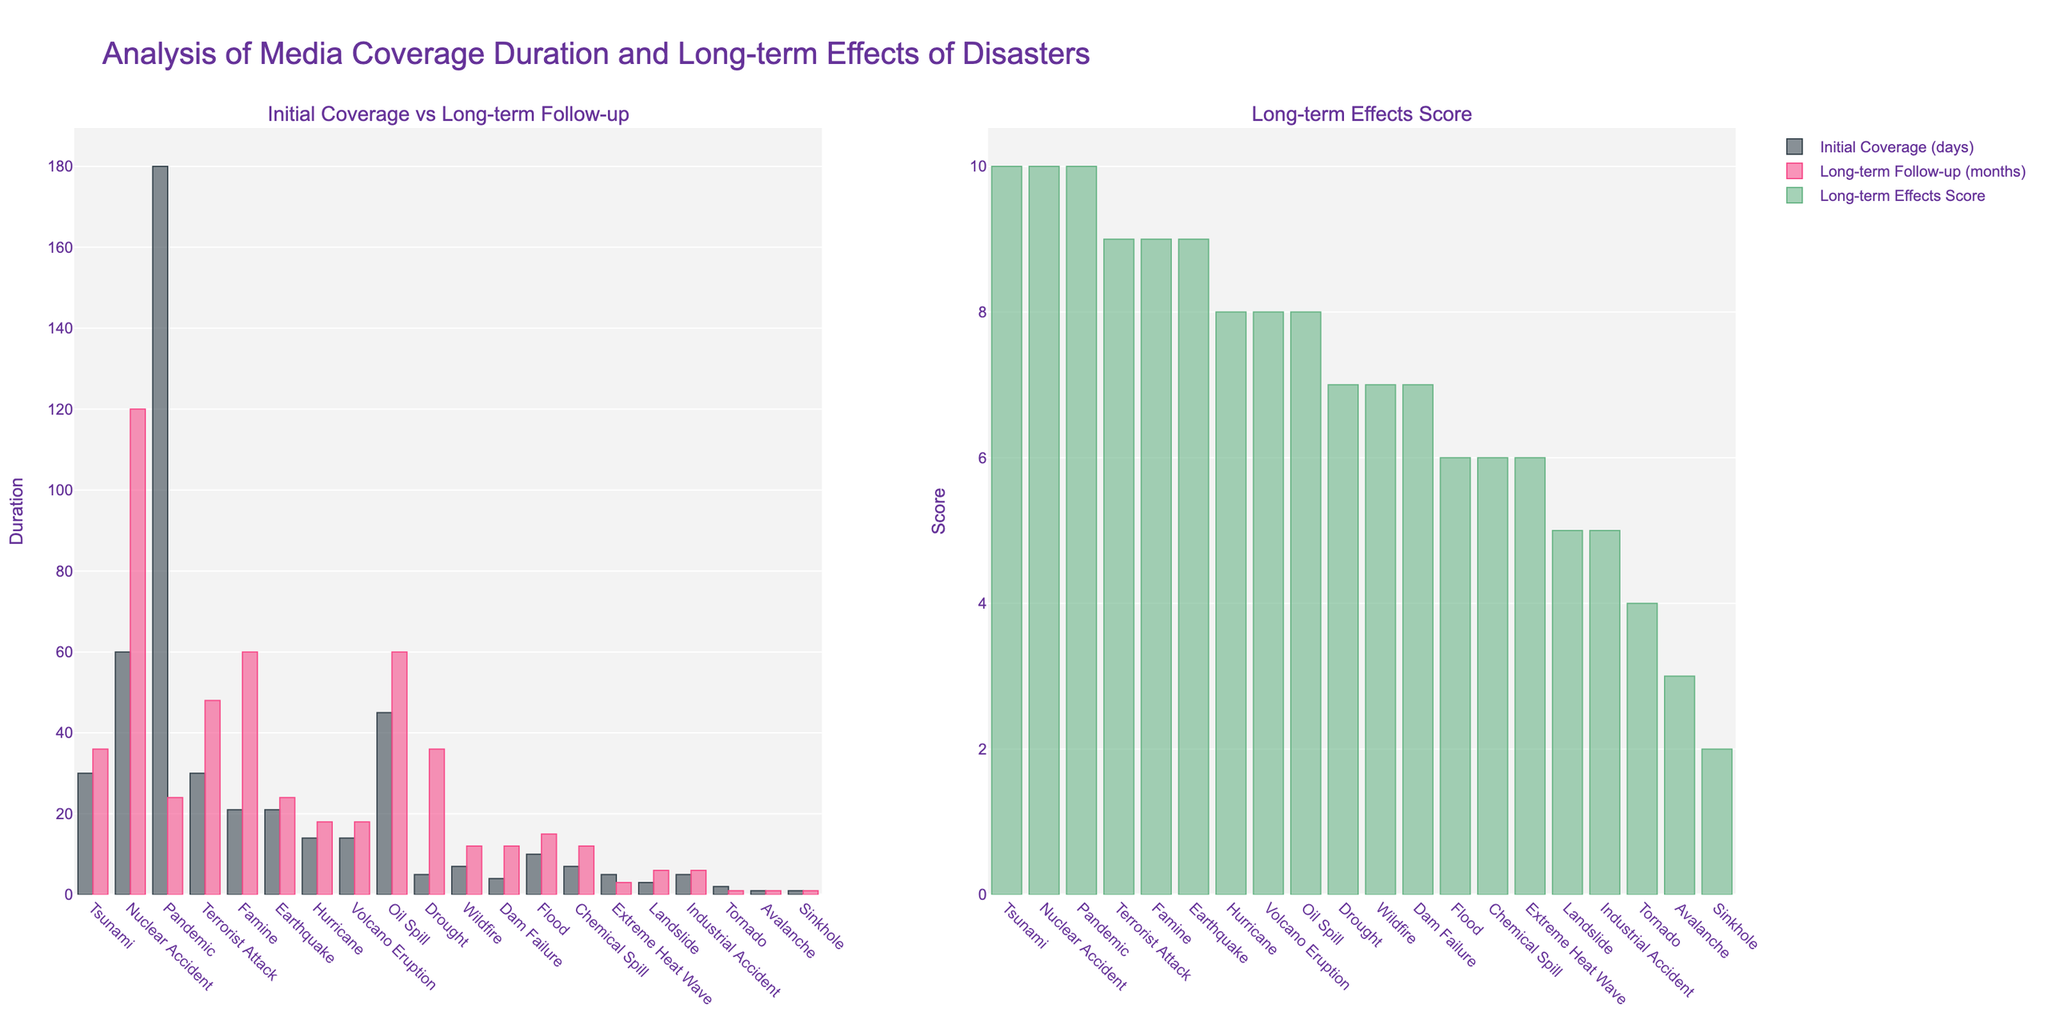What disaster type has the highest initial coverage and what is it? To identify the disaster with the highest initial coverage, observe the height of the bars in the "Initial Coverage (days)" trace. The highest bar represents the disaster with the most days of initial coverage.
Answer: Pandemic, 180 days Which disaster types have the same long-term follow-up duration and what are their values? Compare the heights of the "Long-term Follow-up (months)" bars to find bars of equal height. Identify the disaster types corresponding to these bars and list their values.
Answer: Wildfire, Chemical Spill, and Dam Failure, 12 months What is the difference in initial media coverage between Nuclear Accident and Tornado? Subtract the value of Tornado's initial media coverage from Nuclear Accident's. Nuclear Accident has 60 days, and Tornado has 2 days of initial coverage.
Answer: 58 days Which disaster type has the lowest long-term effects score and what is the score? Identify the smallest bar in the "Long-term Effects Score" graph. Note the disaster type and score associated with this bar.
Answer: Sinkhole, 2 Compare the long-term follow-up of Famine and Tsunami. Which one is longer and by how many months? Look at the "Long-term Follow-up" bars for Famine and Tsunami. Famine has 60 months, and Tsunami has 36 months. Subtract Tsunami's value from Famine's value.
Answer: Famine, 24 months For how many disasters is the long-term follow-up exactly 24 months? Count the number of bars in the "Long-term Follow-up (months)" graph that extend to the 24-month level.
Answer: 2 (Earthquake, Pandemic) Which disaster types have a long-term effects score of 10? Identify the bars in the "Long-term Effects Score" graph that reach the value of 10. Note the disaster types corresponding to these bars.
Answer: Tsunami, Nuclear Accident, Pandemic What is the average initial coverage of disasters with a long-term effects score of 9? First, identify the disasters with a long-term effects score of 9 (Earthquake, Terrorist Attack, Famine). Add their initial coverage values (21, 30, and 21 days) and divide by the number of such disasters.
Answer: 24 days What is the total long-term follow-up duration for both Chemical Spill and Extreme Heat Wave? Add the long-term follow-up durations for Chemical Spill and Extreme Heat Wave. Chemical Spill has 12 months, and Extreme Heat Wave has 3 months.
Answer: 15 months Which disaster type has the highest contrast between initial coverage and long-term follow-up, and what is that difference? Calculate the absolute difference between initial coverage and long-term follow-up for each disaster. Identify the disaster with the largest difference.
Answer: Nuclear Accident, 60 days initial coverage vs 120 months follow-up = 1080 days difference 